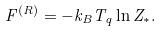<formula> <loc_0><loc_0><loc_500><loc_500>F ^ { ( R ) } = - k _ { B } T _ { q } \ln Z _ { * } .</formula> 